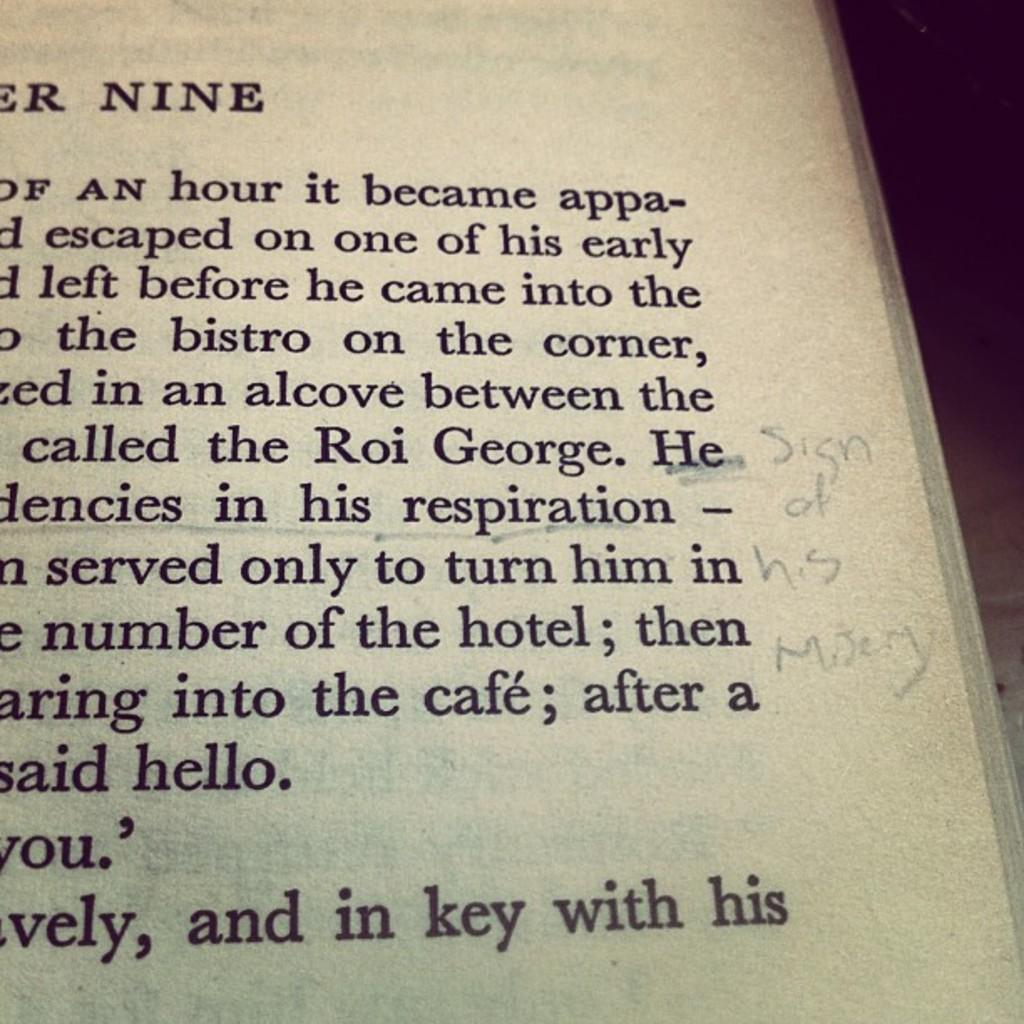<image>
Summarize the visual content of the image. The people in the book are in an alcove called Roi George 